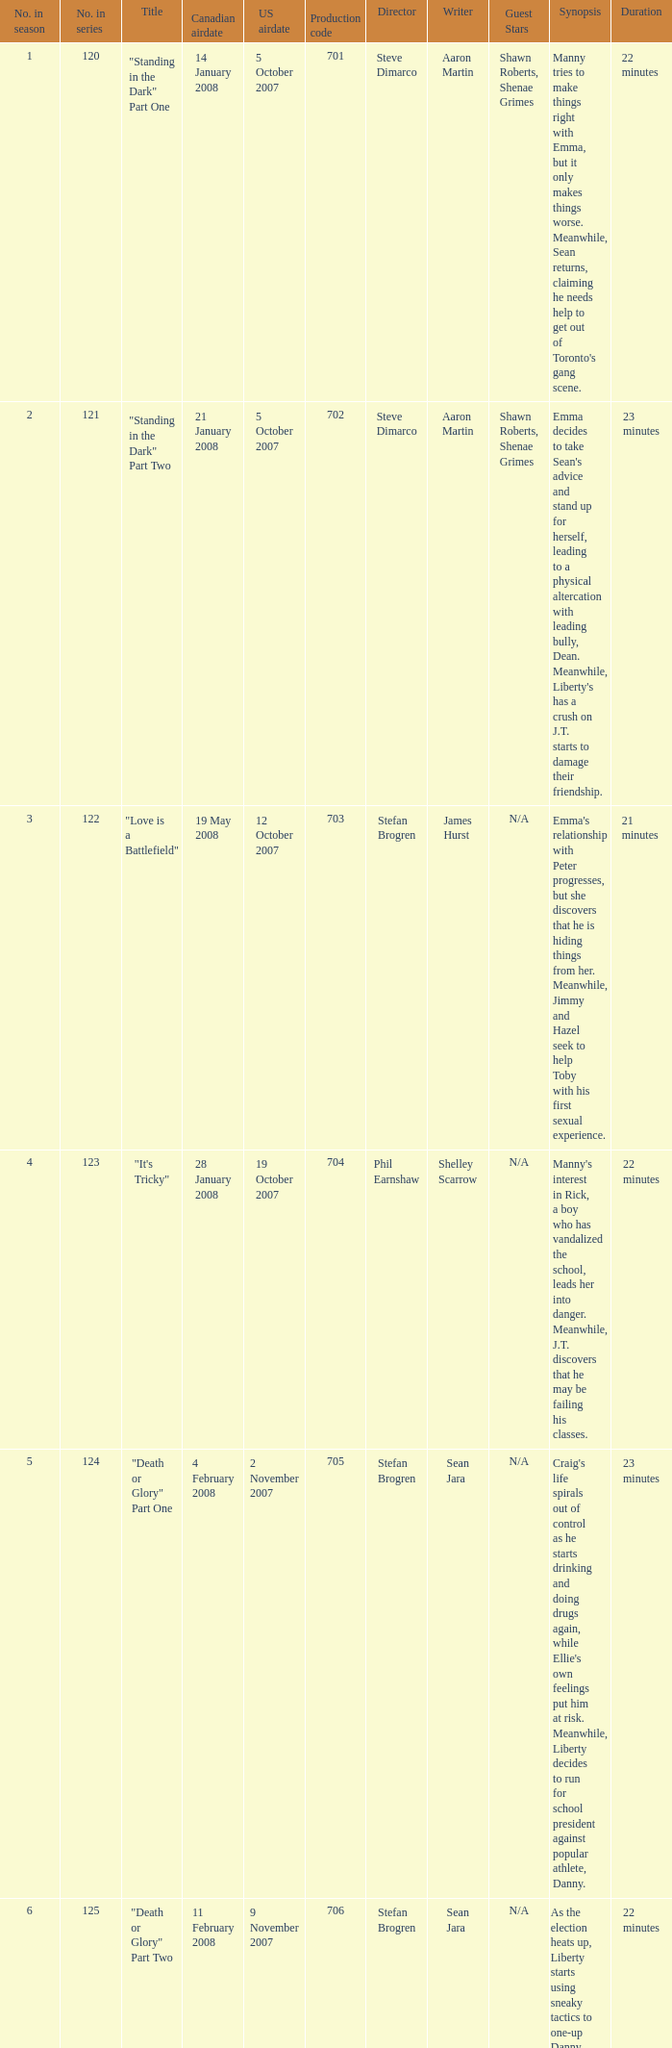The U.S. airdate of 8 august 2008 also had canadian airdates of what? 16 June 2008. 